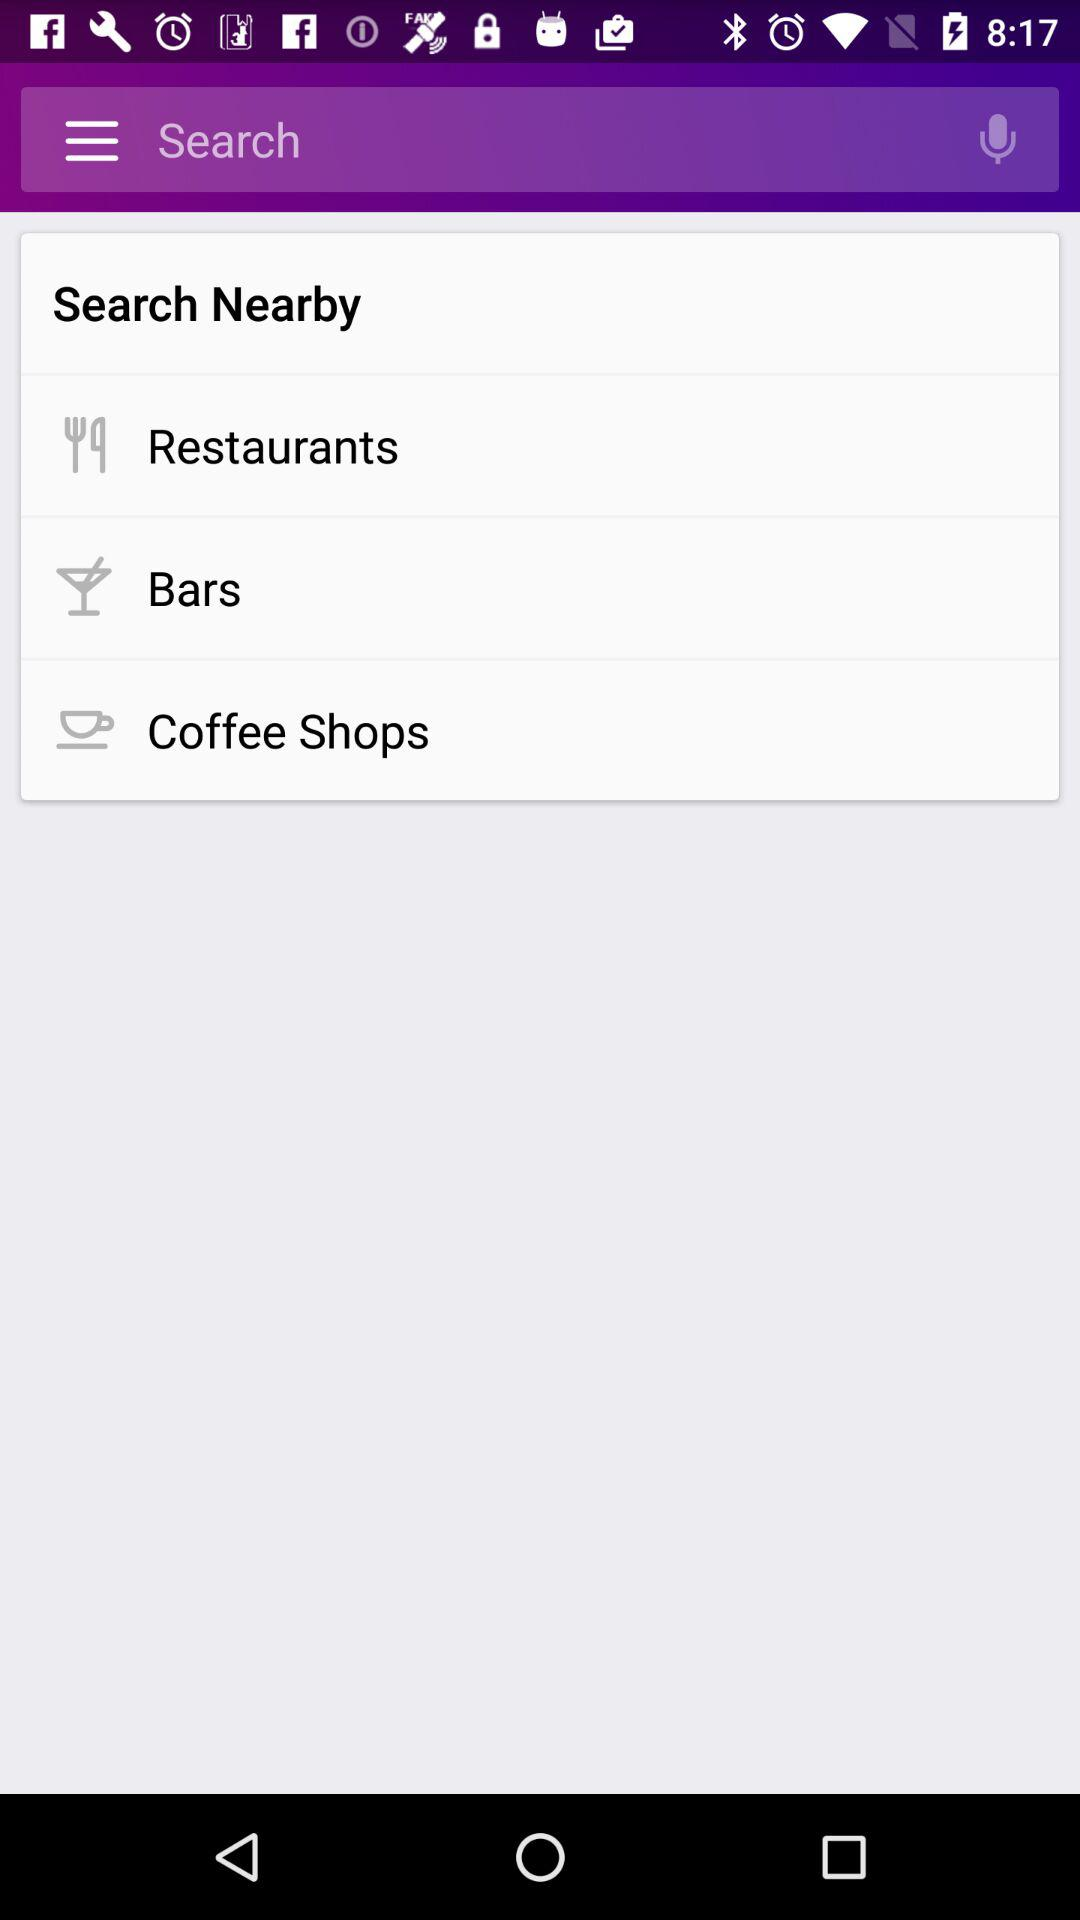What options are available in "Search Nearby"? The available options are "Restaurants", "Bars" and "Coffee Shops". 